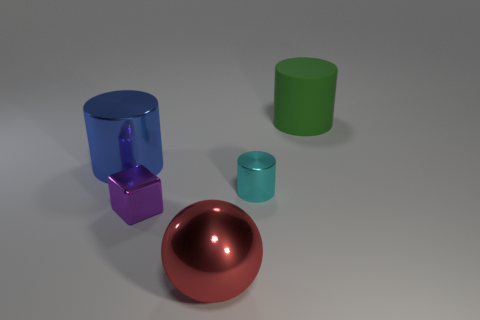There is a large green thing that is the same shape as the cyan object; what is its material?
Provide a succinct answer. Rubber. What material is the big green object?
Keep it short and to the point. Rubber. Are there an equal number of cylinders that are right of the tiny cube and gray rubber blocks?
Provide a succinct answer. No. There is a purple object that is the same size as the cyan thing; what is its shape?
Offer a very short reply. Cube. There is a large metallic thing behind the small purple shiny cube; is there a large metallic cylinder that is behind it?
Your response must be concise. No. What number of small things are either red cylinders or blue metal cylinders?
Offer a terse response. 0. Is there a cyan metallic thing that has the same size as the blue metal object?
Make the answer very short. No. What number of matte things are either tiny purple cubes or big green cylinders?
Give a very brief answer. 1. What number of cyan metallic objects are there?
Make the answer very short. 1. Do the tiny object that is behind the small purple block and the big cylinder in front of the large green object have the same material?
Your answer should be very brief. Yes. 